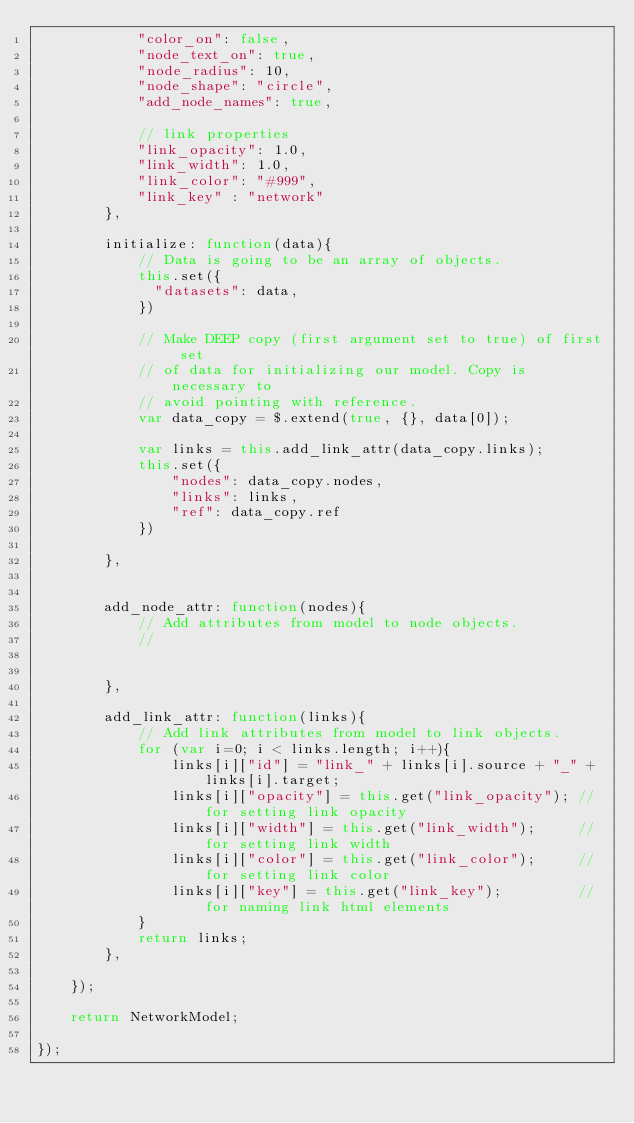Convert code to text. <code><loc_0><loc_0><loc_500><loc_500><_JavaScript_>            "color_on": false,
            "node_text_on": true,
            "node_radius": 10,
            "node_shape": "circle",
            "add_node_names": true,

            // link properties
            "link_opacity": 1.0,
            "link_width": 1.0,
            "link_color": "#999", 
            "link_key" : "network"
        },

        initialize: function(data){
            // Data is going to be an array of objects.
            this.set({
              "datasets": data,
            })

            // Make DEEP copy (first argument set to true) of first set
            // of data for initializing our model. Copy is necessary to
            // avoid pointing with reference.
            var data_copy = $.extend(true, {}, data[0]);
            
            var links = this.add_link_attr(data_copy.links);
            this.set({
                "nodes": data_copy.nodes,
                "links": links,
                "ref": data_copy.ref
            })

        },
        
        
        add_node_attr: function(nodes){
            // Add attributes from model to node objects.
            //
            
            
        },
        
        add_link_attr: function(links){
            // Add link attributes from model to link objects.
            for (var i=0; i < links.length; i++){
                links[i]["id"] = "link_" + links[i].source + "_" + links[i].target;
                links[i]["opacity"] = this.get("link_opacity"); // for setting link opacity
                links[i]["width"] = this.get("link_width");     // for setting link width
                links[i]["color"] = this.get("link_color");     // for setting link color
                links[i]["key"] = this.get("link_key");         // for naming link html elements
            }
            return links;
        },

    });

    return NetworkModel;

});
</code> 